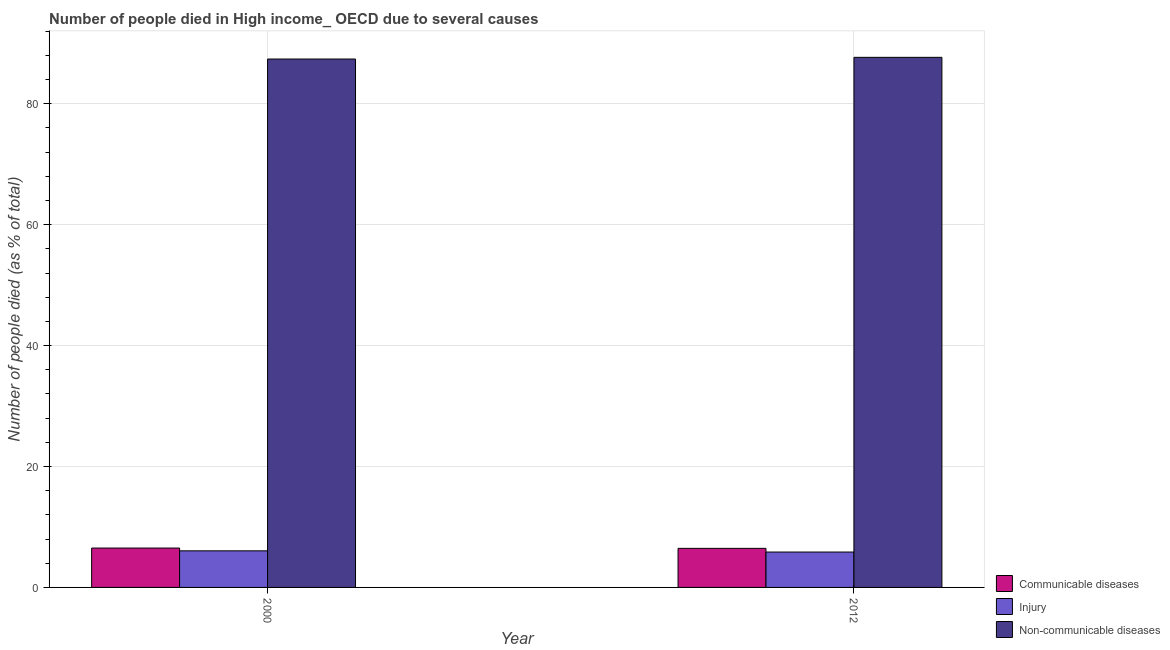How many bars are there on the 1st tick from the left?
Provide a short and direct response. 3. How many bars are there on the 1st tick from the right?
Offer a terse response. 3. In how many cases, is the number of bars for a given year not equal to the number of legend labels?
Provide a succinct answer. 0. What is the number of people who died of communicable diseases in 2012?
Your response must be concise. 6.46. Across all years, what is the maximum number of people who dies of non-communicable diseases?
Offer a very short reply. 87.68. Across all years, what is the minimum number of people who dies of non-communicable diseases?
Provide a short and direct response. 87.4. What is the total number of people who died of injury in the graph?
Ensure brevity in your answer.  11.91. What is the difference between the number of people who died of injury in 2000 and that in 2012?
Ensure brevity in your answer.  0.2. What is the difference between the number of people who died of communicable diseases in 2000 and the number of people who died of injury in 2012?
Keep it short and to the point. 0.05. What is the average number of people who dies of non-communicable diseases per year?
Offer a terse response. 87.54. In how many years, is the number of people who dies of non-communicable diseases greater than 36 %?
Offer a terse response. 2. What is the ratio of the number of people who died of communicable diseases in 2000 to that in 2012?
Make the answer very short. 1.01. In how many years, is the number of people who died of injury greater than the average number of people who died of injury taken over all years?
Make the answer very short. 1. What does the 3rd bar from the left in 2012 represents?
Offer a terse response. Non-communicable diseases. What does the 3rd bar from the right in 2012 represents?
Offer a very short reply. Communicable diseases. Is it the case that in every year, the sum of the number of people who died of communicable diseases and number of people who died of injury is greater than the number of people who dies of non-communicable diseases?
Offer a terse response. No. How many bars are there?
Your answer should be compact. 6. Are all the bars in the graph horizontal?
Give a very brief answer. No. How many years are there in the graph?
Keep it short and to the point. 2. What is the difference between two consecutive major ticks on the Y-axis?
Offer a terse response. 20. Does the graph contain any zero values?
Give a very brief answer. No. Does the graph contain grids?
Your answer should be compact. Yes. How are the legend labels stacked?
Your answer should be compact. Vertical. What is the title of the graph?
Give a very brief answer. Number of people died in High income_ OECD due to several causes. What is the label or title of the Y-axis?
Your answer should be compact. Number of people died (as % of total). What is the Number of people died (as % of total) in Communicable diseases in 2000?
Your response must be concise. 6.51. What is the Number of people died (as % of total) of Injury in 2000?
Provide a short and direct response. 6.05. What is the Number of people died (as % of total) of Non-communicable diseases in 2000?
Make the answer very short. 87.4. What is the Number of people died (as % of total) in Communicable diseases in 2012?
Your answer should be compact. 6.46. What is the Number of people died (as % of total) in Injury in 2012?
Offer a very short reply. 5.85. What is the Number of people died (as % of total) of Non-communicable diseases in 2012?
Keep it short and to the point. 87.68. Across all years, what is the maximum Number of people died (as % of total) of Communicable diseases?
Offer a very short reply. 6.51. Across all years, what is the maximum Number of people died (as % of total) of Injury?
Offer a very short reply. 6.05. Across all years, what is the maximum Number of people died (as % of total) of Non-communicable diseases?
Provide a succinct answer. 87.68. Across all years, what is the minimum Number of people died (as % of total) of Communicable diseases?
Ensure brevity in your answer.  6.46. Across all years, what is the minimum Number of people died (as % of total) in Injury?
Your answer should be very brief. 5.85. Across all years, what is the minimum Number of people died (as % of total) in Non-communicable diseases?
Offer a very short reply. 87.4. What is the total Number of people died (as % of total) in Communicable diseases in the graph?
Offer a terse response. 12.98. What is the total Number of people died (as % of total) in Injury in the graph?
Give a very brief answer. 11.91. What is the total Number of people died (as % of total) in Non-communicable diseases in the graph?
Offer a very short reply. 175.08. What is the difference between the Number of people died (as % of total) of Communicable diseases in 2000 and that in 2012?
Ensure brevity in your answer.  0.05. What is the difference between the Number of people died (as % of total) in Injury in 2000 and that in 2012?
Offer a terse response. 0.2. What is the difference between the Number of people died (as % of total) of Non-communicable diseases in 2000 and that in 2012?
Your answer should be compact. -0.28. What is the difference between the Number of people died (as % of total) in Communicable diseases in 2000 and the Number of people died (as % of total) in Injury in 2012?
Provide a short and direct response. 0.66. What is the difference between the Number of people died (as % of total) in Communicable diseases in 2000 and the Number of people died (as % of total) in Non-communicable diseases in 2012?
Offer a terse response. -81.17. What is the difference between the Number of people died (as % of total) in Injury in 2000 and the Number of people died (as % of total) in Non-communicable diseases in 2012?
Your answer should be very brief. -81.63. What is the average Number of people died (as % of total) of Communicable diseases per year?
Keep it short and to the point. 6.49. What is the average Number of people died (as % of total) in Injury per year?
Your response must be concise. 5.95. What is the average Number of people died (as % of total) in Non-communicable diseases per year?
Keep it short and to the point. 87.54. In the year 2000, what is the difference between the Number of people died (as % of total) of Communicable diseases and Number of people died (as % of total) of Injury?
Offer a terse response. 0.46. In the year 2000, what is the difference between the Number of people died (as % of total) of Communicable diseases and Number of people died (as % of total) of Non-communicable diseases?
Provide a succinct answer. -80.89. In the year 2000, what is the difference between the Number of people died (as % of total) in Injury and Number of people died (as % of total) in Non-communicable diseases?
Offer a terse response. -81.35. In the year 2012, what is the difference between the Number of people died (as % of total) in Communicable diseases and Number of people died (as % of total) in Injury?
Make the answer very short. 0.61. In the year 2012, what is the difference between the Number of people died (as % of total) of Communicable diseases and Number of people died (as % of total) of Non-communicable diseases?
Offer a very short reply. -81.22. In the year 2012, what is the difference between the Number of people died (as % of total) of Injury and Number of people died (as % of total) of Non-communicable diseases?
Your answer should be compact. -81.83. What is the ratio of the Number of people died (as % of total) of Communicable diseases in 2000 to that in 2012?
Offer a very short reply. 1.01. What is the ratio of the Number of people died (as % of total) of Injury in 2000 to that in 2012?
Offer a terse response. 1.03. What is the ratio of the Number of people died (as % of total) of Non-communicable diseases in 2000 to that in 2012?
Provide a succinct answer. 1. What is the difference between the highest and the second highest Number of people died (as % of total) in Communicable diseases?
Offer a terse response. 0.05. What is the difference between the highest and the second highest Number of people died (as % of total) of Injury?
Give a very brief answer. 0.2. What is the difference between the highest and the second highest Number of people died (as % of total) of Non-communicable diseases?
Give a very brief answer. 0.28. What is the difference between the highest and the lowest Number of people died (as % of total) of Communicable diseases?
Your response must be concise. 0.05. What is the difference between the highest and the lowest Number of people died (as % of total) of Injury?
Your answer should be compact. 0.2. What is the difference between the highest and the lowest Number of people died (as % of total) of Non-communicable diseases?
Offer a terse response. 0.28. 